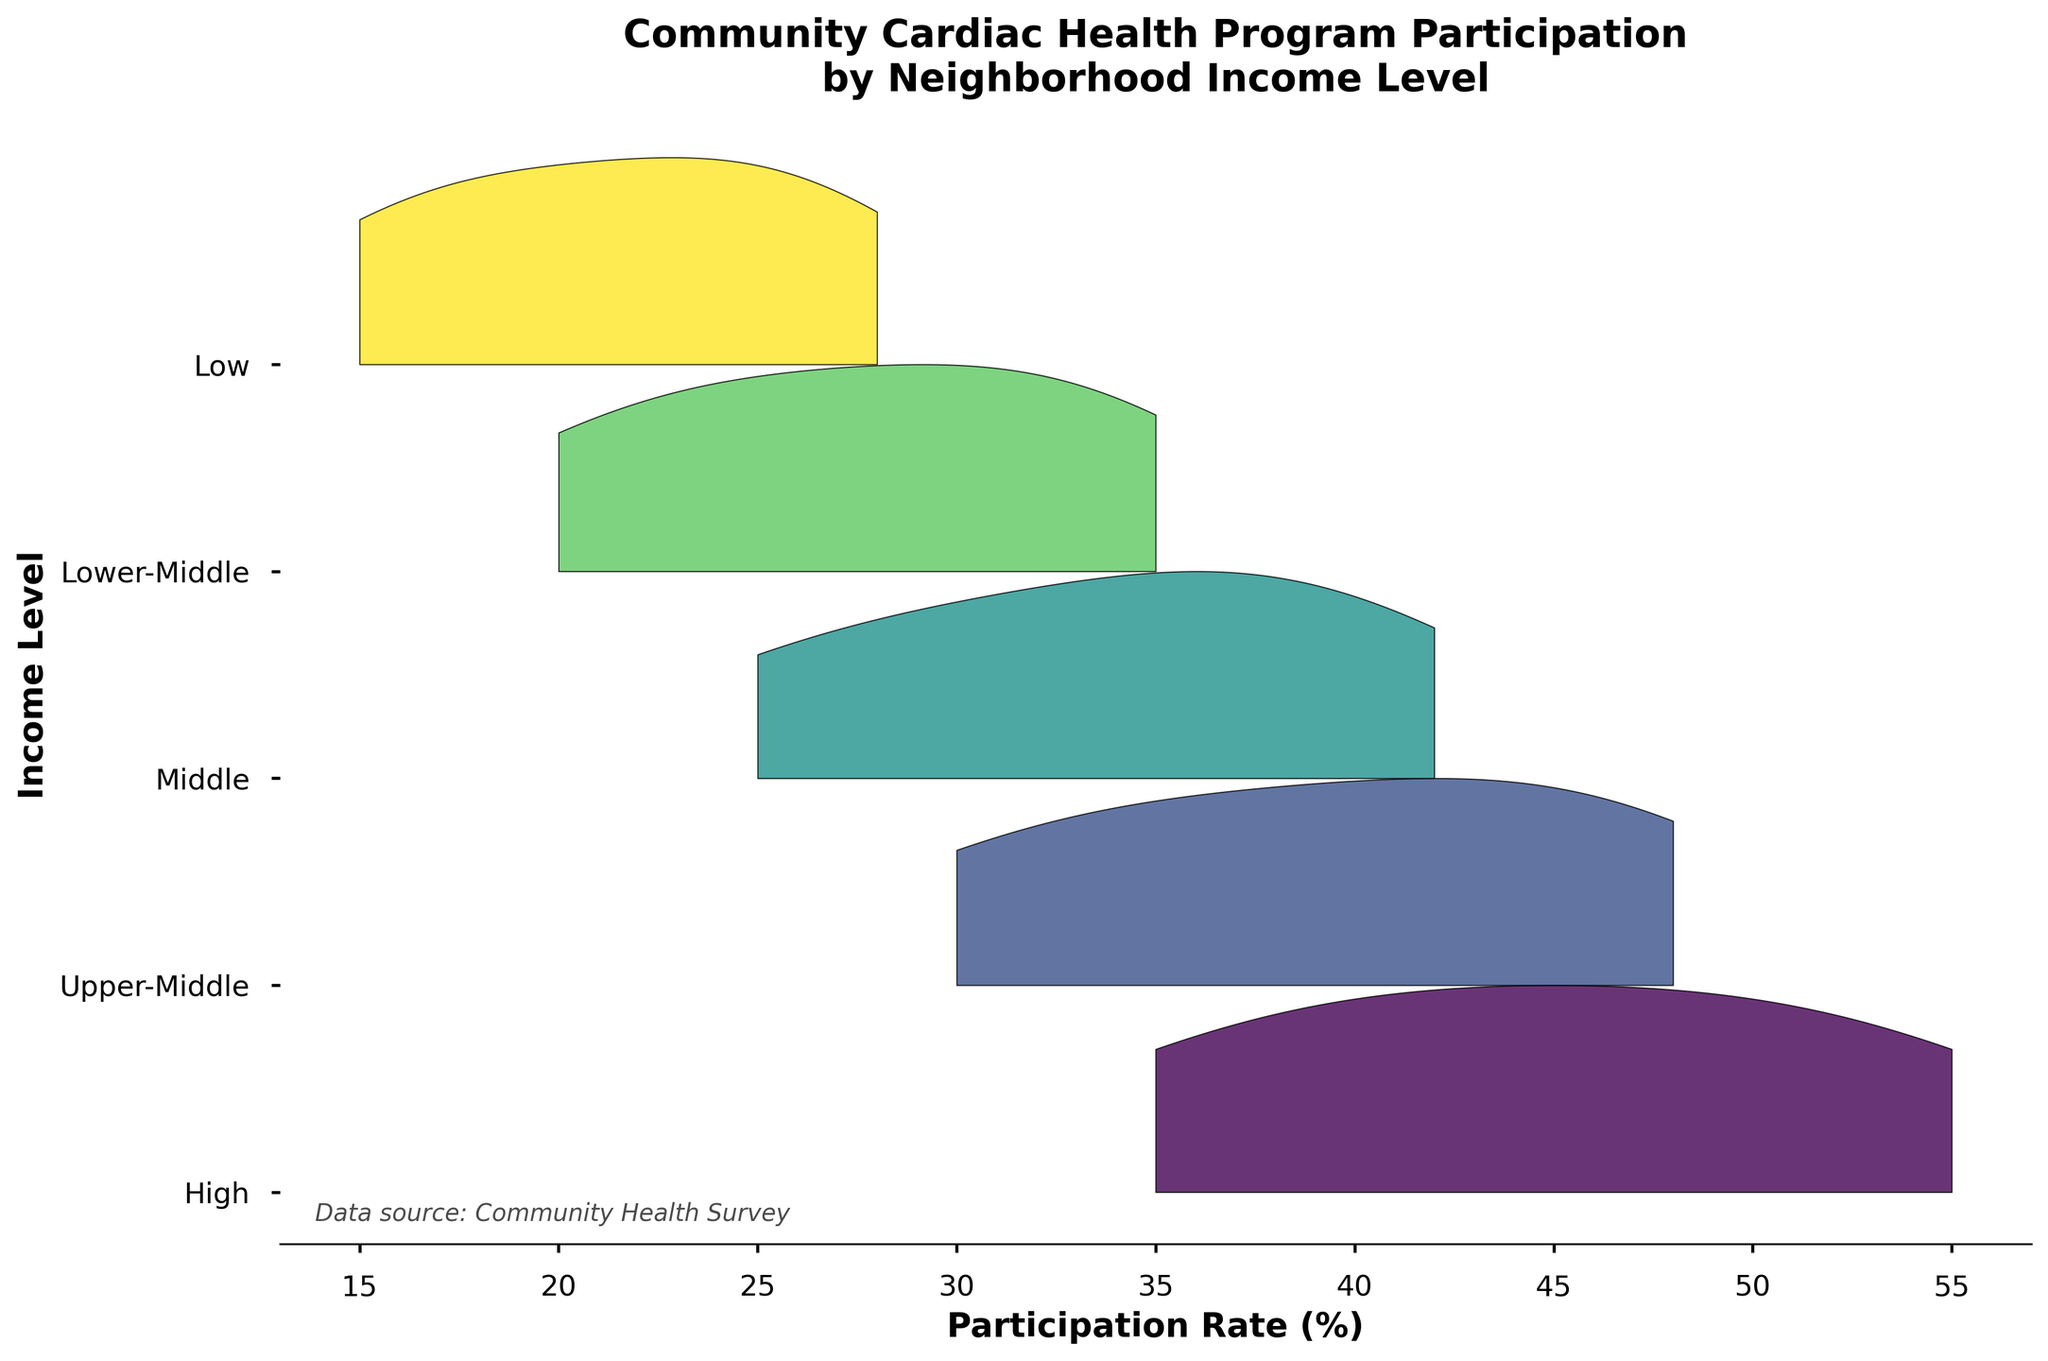What's the title of the plot? The title is usually prominently displayed at the top of the plot. Here, it can be found as “Community Cardiac Health Program Participation by Neighborhood Income Level” at the top.
Answer: Community Cardiac Health Program Participation by Neighborhood Income Level What does the x-axis represent? The x-axis represents the participation rate (%) in the community cardiac health programs, indicated by the label "Participation Rate (%)" along the horizontal axis.
Answer: Participation Rate (%) What does the y-axis represent? The y-axis represents the different neighborhood income levels, indicated by the label "Income Level" along the vertical axis, with categories such as "Low," "Lower-Middle," etc.
Answer: Income Level Which income level has the highest participation rate? By examining the plot, the income level with the highest participation rate can be observed from the peak of the density curve that extends the furthest to the right. Here, "High" income level reaches up to 55%.
Answer: High Which income level has the lowest participation rate? The income level with the lowest participation rate can be identified by looking at the smallest value on the x-axis for any ridge line. Here, the "Low" income level has the lowest participation rate starting at 15%.
Answer: Low How do the participation rates compare between Lower-Middle and Upper-Middle income levels? The plot shows the participation rates for "Lower-Middle" and "Upper-Middle" income levels. The "Lower-Middle" income level ranges from 20% to 35%, while "Upper-Middle" ranges from 30% to 48%.
Answer: Upper-Middle has higher participation rates compared to Lower-Middle What range of participation rates does the "Middle" income level cover? Observing the plot, the "Middle" income level's participation rates can be seen from the leftmost to the rightmost extent of the ridge line of "Middle." Here, it ranges from 25% to 42%.
Answer: 25% to 42% Between which two income levels is the difference in maximum participation rate the smallest? By looking at the maximum participation rates for each income level, the smallest difference can be calculated. "Middle" has a maximum of 42%, and "Lower-Middle" has 35%, giving a difference of 7%, which is the smallest among all pairs.
Answer: Middle and Lower-Middle How does the density of participation rates differ among income levels? Density differences among income levels can be observed from the area under each curve. "High" and "Upper-Middle" income levels have broader and more spread-out curves, indicating higher variance, whereas "Lower-Middle" and "Low" income levels have narrower curves, suggesting lower variance.
Answer: High and Upper-Middle have higher variance; Lower-Middle and Low have lower variance What does the overall shape of the plot suggest about participation rates across different income levels? The plot's ridgeline format shows that higher income levels ("High" and "Upper-Middle") tend to have higher participation rates, while lower income levels ("Low" and "Lower-Middle") tend to have lower rates. This suggests socioeconomic factors influence participation in cardiac health programs.
Answer: Higher income levels have higher participation rates than lower income levels 